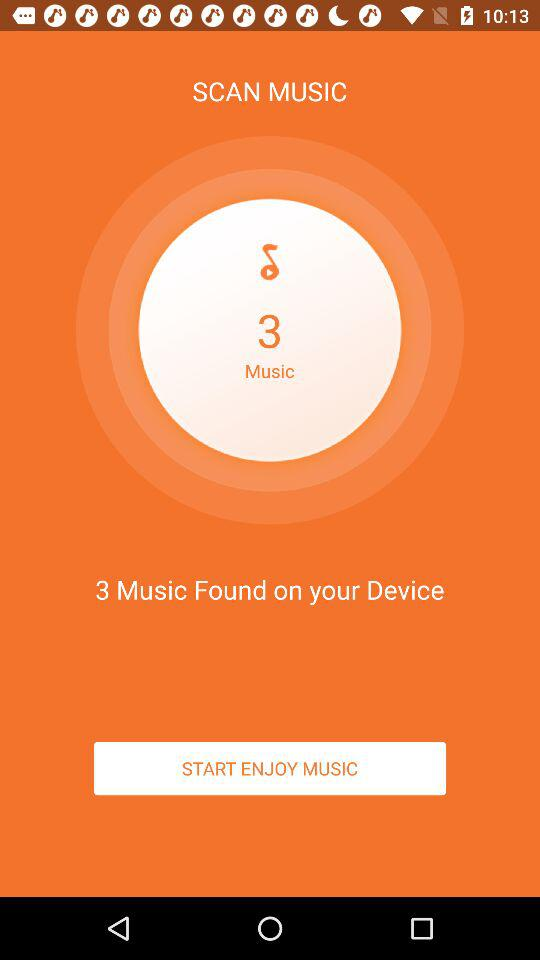How many musics have been found on the device? The number of musics found on the device is 3. 